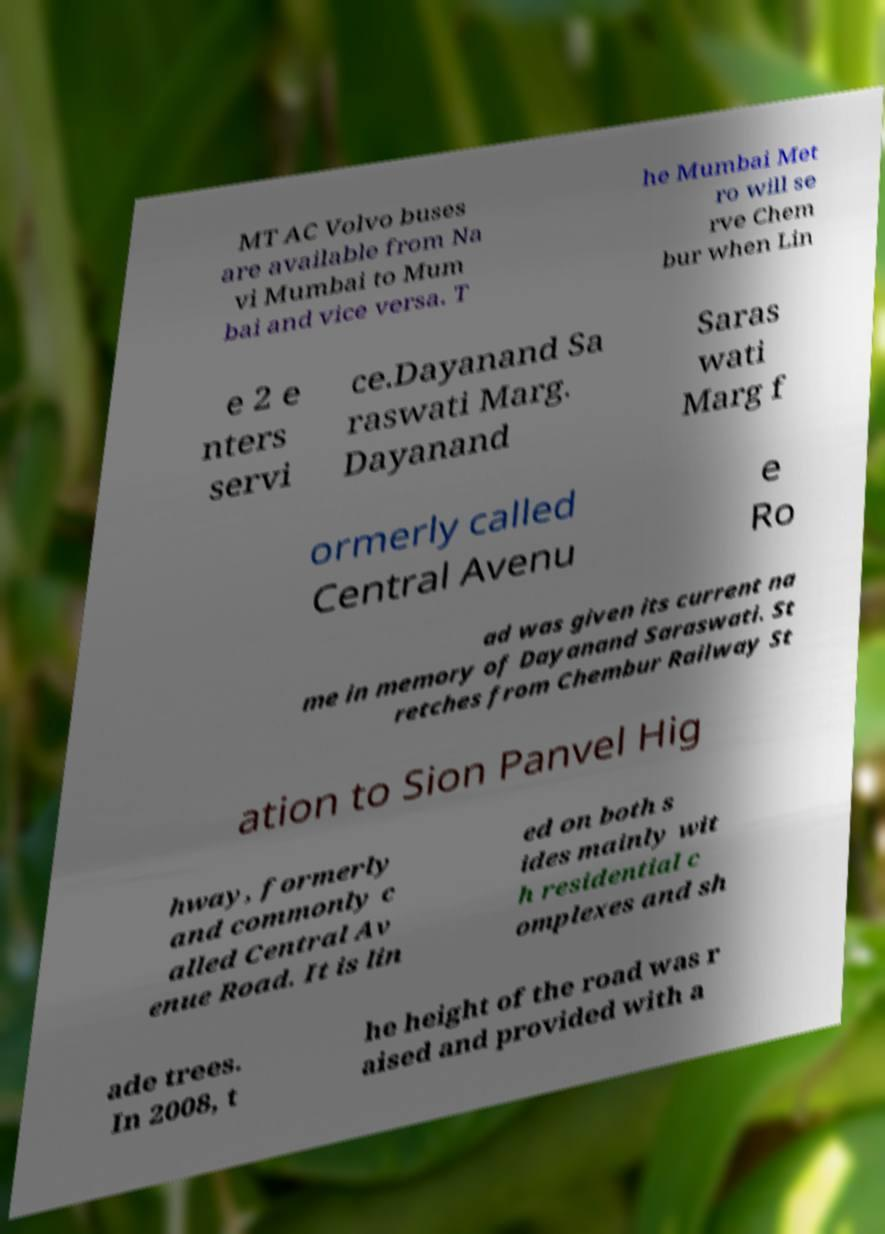There's text embedded in this image that I need extracted. Can you transcribe it verbatim? MT AC Volvo buses are available from Na vi Mumbai to Mum bai and vice versa. T he Mumbai Met ro will se rve Chem bur when Lin e 2 e nters servi ce.Dayanand Sa raswati Marg. Dayanand Saras wati Marg f ormerly called Central Avenu e Ro ad was given its current na me in memory of Dayanand Saraswati. St retches from Chembur Railway St ation to Sion Panvel Hig hway, formerly and commonly c alled Central Av enue Road. It is lin ed on both s ides mainly wit h residential c omplexes and sh ade trees. In 2008, t he height of the road was r aised and provided with a 